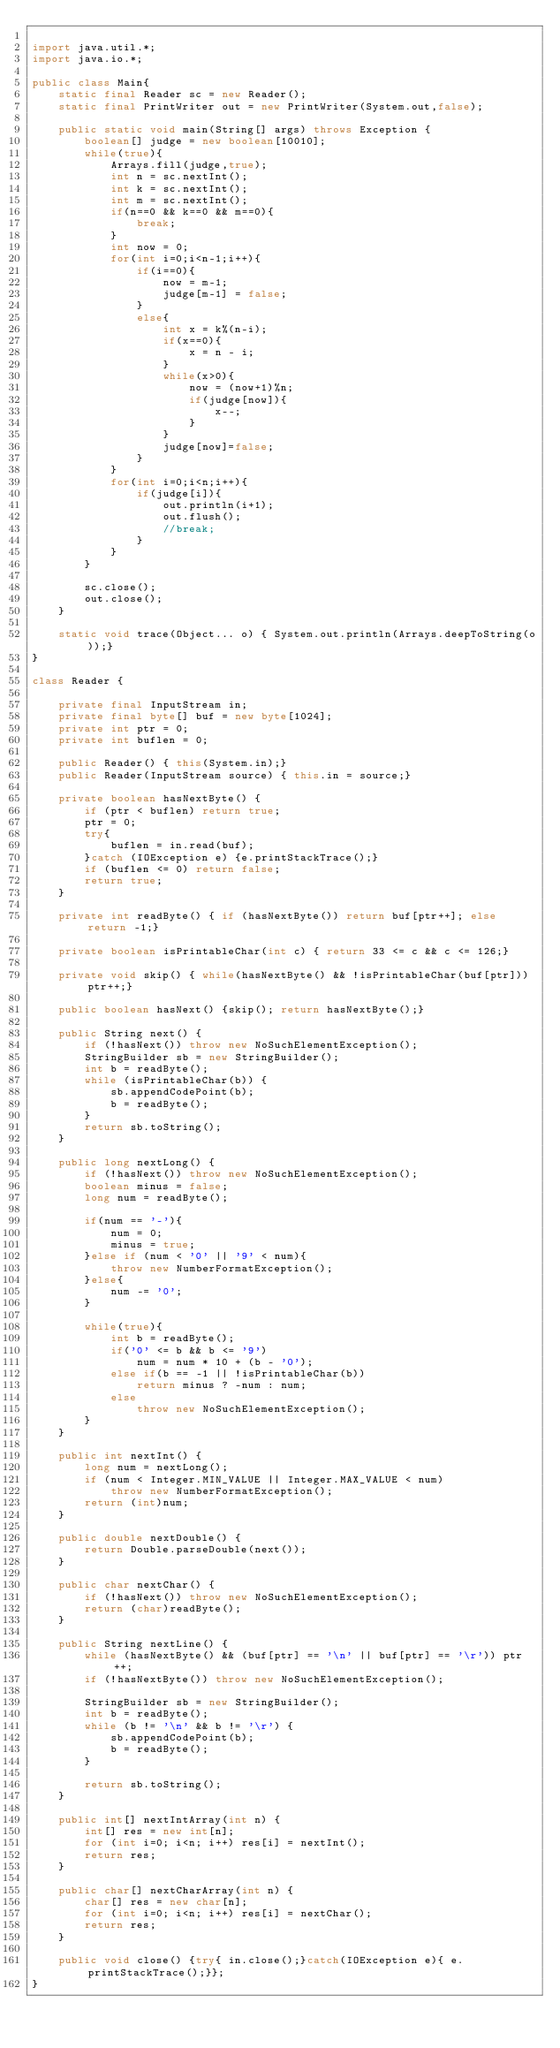<code> <loc_0><loc_0><loc_500><loc_500><_Java_>
import java.util.*;
import java.io.*;

public class Main{
    static final Reader sc = new Reader();
    static final PrintWriter out = new PrintWriter(System.out,false);

    public static void main(String[] args) throws Exception {
    	boolean[] judge = new boolean[10010];
    	while(true){
    		Arrays.fill(judge,true);
    		int n = sc.nextInt();
    		int k = sc.nextInt();
    		int m = sc.nextInt();
    		if(n==0 && k==0 && m==0){
    			break;
    		}
    		int now = 0;
    		for(int i=0;i<n-1;i++){
    			if(i==0){
    				now = m-1;
    				judge[m-1] = false;
    			}
    			else{
    				int x = k%(n-i);
    				if(x==0){
    					x = n - i;
    				}
    				while(x>0){
    					now = (now+1)%n;
    					if(judge[now]){
    						x--;
    					}
    				}
    				judge[now]=false;
    			}
    		}
    		for(int i=0;i<n;i++){
    			if(judge[i]){
    				out.println(i+1);
    				out.flush();
    				//break;
    			}
    		}
    	}

        sc.close();
        out.close();
    }

    static void trace(Object... o) { System.out.println(Arrays.deepToString(o));}
}

class Reader {

    private final InputStream in;
    private final byte[] buf = new byte[1024];
    private int ptr = 0;
    private int buflen = 0;

    public Reader() { this(System.in);}
    public Reader(InputStream source) { this.in = source;}

    private boolean hasNextByte() {
        if (ptr < buflen) return true;
        ptr = 0;
        try{
            buflen = in.read(buf);
        }catch (IOException e) {e.printStackTrace();}
        if (buflen <= 0) return false;
        return true;
    }

    private int readByte() { if (hasNextByte()) return buf[ptr++]; else return -1;}

    private boolean isPrintableChar(int c) { return 33 <= c && c <= 126;}

    private void skip() { while(hasNextByte() && !isPrintableChar(buf[ptr])) ptr++;}

    public boolean hasNext() {skip(); return hasNextByte();}

    public String next() {
        if (!hasNext()) throw new NoSuchElementException();
        StringBuilder sb = new StringBuilder();
        int b = readByte();
        while (isPrintableChar(b)) {
            sb.appendCodePoint(b);
            b = readByte();
        }
        return sb.toString();
    }

    public long nextLong() {
        if (!hasNext()) throw new NoSuchElementException();
        boolean minus = false;
        long num = readByte();

        if(num == '-'){
            num = 0;
            minus = true;
        }else if (num < '0' || '9' < num){
            throw new NumberFormatException();
        }else{
            num -= '0';
        }

        while(true){
            int b = readByte();
            if('0' <= b && b <= '9')
                num = num * 10 + (b - '0');
            else if(b == -1 || !isPrintableChar(b))
                return minus ? -num : num;
            else
                throw new NoSuchElementException();
        }
    }

    public int nextInt() {
        long num = nextLong();
        if (num < Integer.MIN_VALUE || Integer.MAX_VALUE < num)
            throw new NumberFormatException();
        return (int)num;
    }

    public double nextDouble() {
        return Double.parseDouble(next());
    }

    public char nextChar() {
        if (!hasNext()) throw new NoSuchElementException();
        return (char)readByte();
    }

    public String nextLine() {
        while (hasNextByte() && (buf[ptr] == '\n' || buf[ptr] == '\r')) ptr++;
        if (!hasNextByte()) throw new NoSuchElementException();

        StringBuilder sb = new StringBuilder();
        int b = readByte();
        while (b != '\n' && b != '\r') {
            sb.appendCodePoint(b);
            b = readByte();
        }

        return sb.toString();
    }

    public int[] nextIntArray(int n) {
        int[] res = new int[n];
        for (int i=0; i<n; i++) res[i] = nextInt();
        return res;
    }

    public char[] nextCharArray(int n) {
        char[] res = new char[n];
        for (int i=0; i<n; i++) res[i] = nextChar();
        return res;
    }

    public void close() {try{ in.close();}catch(IOException e){ e.printStackTrace();}};
}</code> 